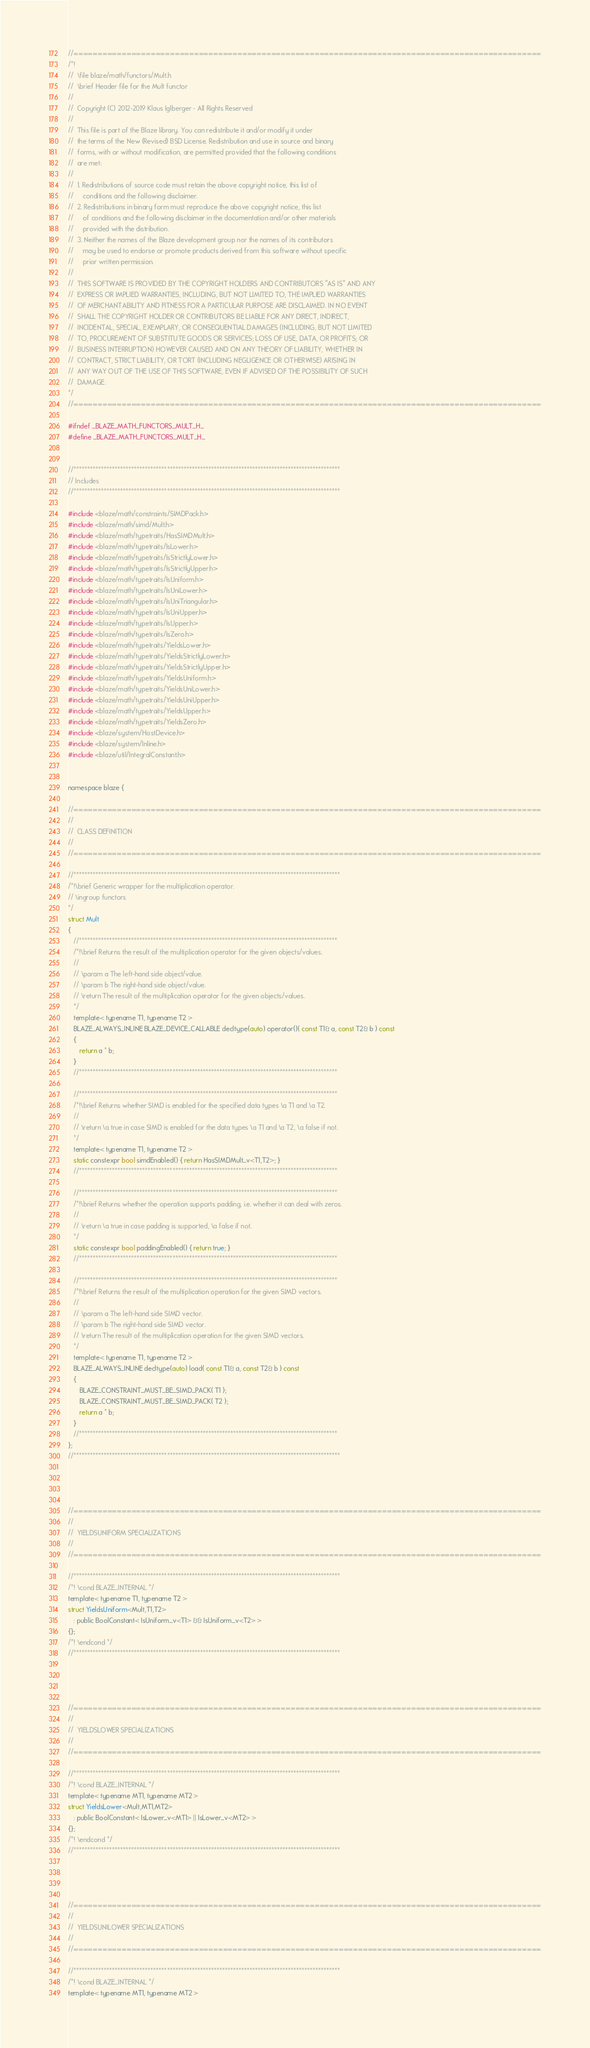<code> <loc_0><loc_0><loc_500><loc_500><_C_>//=================================================================================================
/*!
//  \file blaze/math/functors/Mult.h
//  \brief Header file for the Mult functor
//
//  Copyright (C) 2012-2019 Klaus Iglberger - All Rights Reserved
//
//  This file is part of the Blaze library. You can redistribute it and/or modify it under
//  the terms of the New (Revised) BSD License. Redistribution and use in source and binary
//  forms, with or without modification, are permitted provided that the following conditions
//  are met:
//
//  1. Redistributions of source code must retain the above copyright notice, this list of
//     conditions and the following disclaimer.
//  2. Redistributions in binary form must reproduce the above copyright notice, this list
//     of conditions and the following disclaimer in the documentation and/or other materials
//     provided with the distribution.
//  3. Neither the names of the Blaze development group nor the names of its contributors
//     may be used to endorse or promote products derived from this software without specific
//     prior written permission.
//
//  THIS SOFTWARE IS PROVIDED BY THE COPYRIGHT HOLDERS AND CONTRIBUTORS "AS IS" AND ANY
//  EXPRESS OR IMPLIED WARRANTIES, INCLUDING, BUT NOT LIMITED TO, THE IMPLIED WARRANTIES
//  OF MERCHANTABILITY AND FITNESS FOR A PARTICULAR PURPOSE ARE DISCLAIMED. IN NO EVENT
//  SHALL THE COPYRIGHT HOLDER OR CONTRIBUTORS BE LIABLE FOR ANY DIRECT, INDIRECT,
//  INCIDENTAL, SPECIAL, EXEMPLARY, OR CONSEQUENTIAL DAMAGES (INCLUDING, BUT NOT LIMITED
//  TO, PROCUREMENT OF SUBSTITUTE GOODS OR SERVICES; LOSS OF USE, DATA, OR PROFITS; OR
//  BUSINESS INTERRUPTION) HOWEVER CAUSED AND ON ANY THEORY OF LIABILITY, WHETHER IN
//  CONTRACT, STRICT LIABILITY, OR TORT (INCLUDING NEGLIGENCE OR OTHERWISE) ARISING IN
//  ANY WAY OUT OF THE USE OF THIS SOFTWARE, EVEN IF ADVISED OF THE POSSIBILITY OF SUCH
//  DAMAGE.
*/
//=================================================================================================

#ifndef _BLAZE_MATH_FUNCTORS_MULT_H_
#define _BLAZE_MATH_FUNCTORS_MULT_H_


//*************************************************************************************************
// Includes
//*************************************************************************************************

#include <blaze/math/constraints/SIMDPack.h>
#include <blaze/math/simd/Mult.h>
#include <blaze/math/typetraits/HasSIMDMult.h>
#include <blaze/math/typetraits/IsLower.h>
#include <blaze/math/typetraits/IsStrictlyLower.h>
#include <blaze/math/typetraits/IsStrictlyUpper.h>
#include <blaze/math/typetraits/IsUniform.h>
#include <blaze/math/typetraits/IsUniLower.h>
#include <blaze/math/typetraits/IsUniTriangular.h>
#include <blaze/math/typetraits/IsUniUpper.h>
#include <blaze/math/typetraits/IsUpper.h>
#include <blaze/math/typetraits/IsZero.h>
#include <blaze/math/typetraits/YieldsLower.h>
#include <blaze/math/typetraits/YieldsStrictlyLower.h>
#include <blaze/math/typetraits/YieldsStrictlyUpper.h>
#include <blaze/math/typetraits/YieldsUniform.h>
#include <blaze/math/typetraits/YieldsUniLower.h>
#include <blaze/math/typetraits/YieldsUniUpper.h>
#include <blaze/math/typetraits/YieldsUpper.h>
#include <blaze/math/typetraits/YieldsZero.h>
#include <blaze/system/HostDevice.h>
#include <blaze/system/Inline.h>
#include <blaze/util/IntegralConstant.h>


namespace blaze {

//=================================================================================================
//
//  CLASS DEFINITION
//
//=================================================================================================

//*************************************************************************************************
/*!\brief Generic wrapper for the multiplication operator.
// \ingroup functors
*/
struct Mult
{
   //**********************************************************************************************
   /*!\brief Returns the result of the multiplication operator for the given objects/values.
   //
   // \param a The left-hand side object/value.
   // \param b The right-hand side object/value.
   // \return The result of the multiplication operator for the given objects/values.
   */
   template< typename T1, typename T2 >
   BLAZE_ALWAYS_INLINE BLAZE_DEVICE_CALLABLE decltype(auto) operator()( const T1& a, const T2& b ) const
   {
      return a * b;
   }
   //**********************************************************************************************

   //**********************************************************************************************
   /*!\brief Returns whether SIMD is enabled for the specified data types \a T1 and \a T2.
   //
   // \return \a true in case SIMD is enabled for the data types \a T1 and \a T2, \a false if not.
   */
   template< typename T1, typename T2 >
   static constexpr bool simdEnabled() { return HasSIMDMult_v<T1,T2>; }
   //**********************************************************************************************

   //**********************************************************************************************
   /*!\brief Returns whether the operation supports padding, i.e. whether it can deal with zeros.
   //
   // \return \a true in case padding is supported, \a false if not.
   */
   static constexpr bool paddingEnabled() { return true; }
   //**********************************************************************************************

   //**********************************************************************************************
   /*!\brief Returns the result of the multiplication operation for the given SIMD vectors.
   //
   // \param a The left-hand side SIMD vector.
   // \param b The right-hand side SIMD vector.
   // \return The result of the multiplication operation for the given SIMD vectors.
   */
   template< typename T1, typename T2 >
   BLAZE_ALWAYS_INLINE decltype(auto) load( const T1& a, const T2& b ) const
   {
      BLAZE_CONSTRAINT_MUST_BE_SIMD_PACK( T1 );
      BLAZE_CONSTRAINT_MUST_BE_SIMD_PACK( T2 );
      return a * b;
   }
   //**********************************************************************************************
};
//*************************************************************************************************




//=================================================================================================
//
//  YIELDSUNIFORM SPECIALIZATIONS
//
//=================================================================================================

//*************************************************************************************************
/*! \cond BLAZE_INTERNAL */
template< typename T1, typename T2 >
struct YieldsUniform<Mult,T1,T2>
   : public BoolConstant< IsUniform_v<T1> && IsUniform_v<T2> >
{};
/*! \endcond */
//*************************************************************************************************




//=================================================================================================
//
//  YIELDSLOWER SPECIALIZATIONS
//
//=================================================================================================

//*************************************************************************************************
/*! \cond BLAZE_INTERNAL */
template< typename MT1, typename MT2 >
struct YieldsLower<Mult,MT1,MT2>
   : public BoolConstant< IsLower_v<MT1> || IsLower_v<MT2> >
{};
/*! \endcond */
//*************************************************************************************************




//=================================================================================================
//
//  YIELDSUNILOWER SPECIALIZATIONS
//
//=================================================================================================

//*************************************************************************************************
/*! \cond BLAZE_INTERNAL */
template< typename MT1, typename MT2 ></code> 